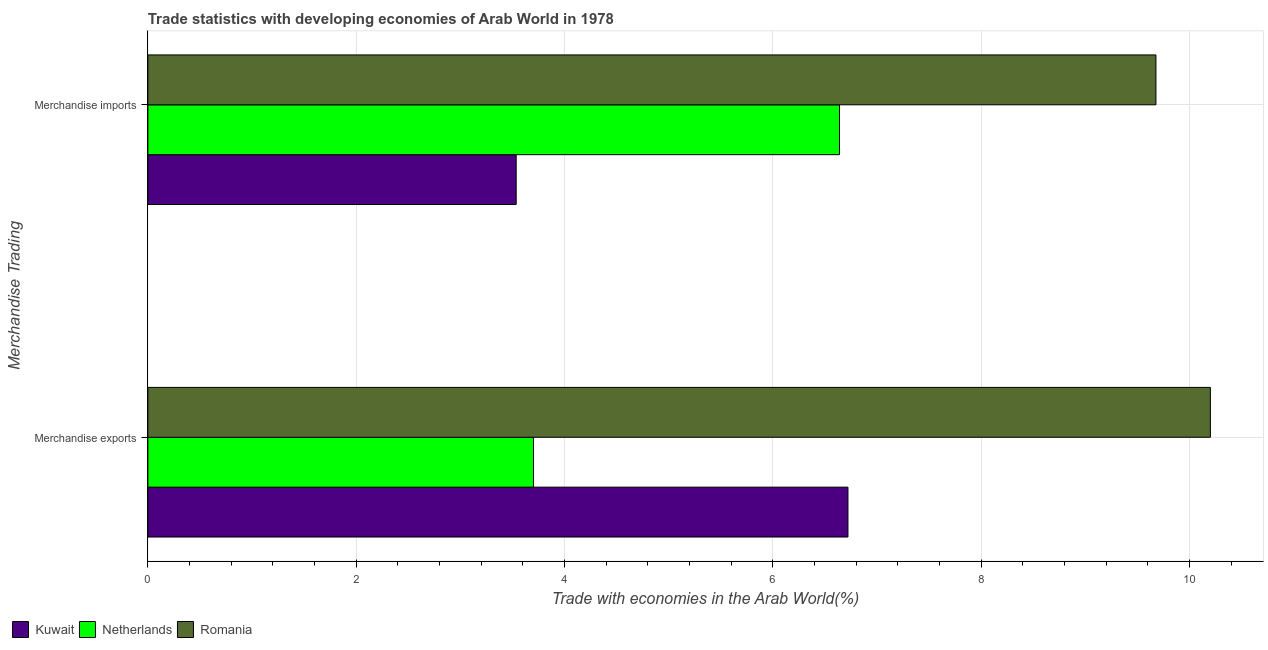Are the number of bars on each tick of the Y-axis equal?
Give a very brief answer. Yes. How many bars are there on the 2nd tick from the top?
Offer a very short reply. 3. What is the merchandise imports in Kuwait?
Provide a succinct answer. 3.54. Across all countries, what is the maximum merchandise imports?
Offer a terse response. 9.68. Across all countries, what is the minimum merchandise exports?
Give a very brief answer. 3.7. In which country was the merchandise imports maximum?
Your answer should be very brief. Romania. In which country was the merchandise imports minimum?
Give a very brief answer. Kuwait. What is the total merchandise exports in the graph?
Provide a short and direct response. 20.62. What is the difference between the merchandise exports in Romania and that in Netherlands?
Keep it short and to the point. 6.5. What is the difference between the merchandise imports in Romania and the merchandise exports in Netherlands?
Your answer should be compact. 5.98. What is the average merchandise imports per country?
Offer a very short reply. 6.62. What is the difference between the merchandise imports and merchandise exports in Romania?
Provide a short and direct response. -0.52. What is the ratio of the merchandise imports in Romania to that in Kuwait?
Your answer should be compact. 2.74. What does the 1st bar from the top in Merchandise imports represents?
Give a very brief answer. Romania. How many bars are there?
Give a very brief answer. 6. Are all the bars in the graph horizontal?
Keep it short and to the point. Yes. Are the values on the major ticks of X-axis written in scientific E-notation?
Give a very brief answer. No. Does the graph contain any zero values?
Offer a very short reply. No. Does the graph contain grids?
Your answer should be very brief. Yes. Where does the legend appear in the graph?
Make the answer very short. Bottom left. How many legend labels are there?
Offer a terse response. 3. What is the title of the graph?
Offer a terse response. Trade statistics with developing economies of Arab World in 1978. What is the label or title of the X-axis?
Offer a terse response. Trade with economies in the Arab World(%). What is the label or title of the Y-axis?
Make the answer very short. Merchandise Trading. What is the Trade with economies in the Arab World(%) of Kuwait in Merchandise exports?
Ensure brevity in your answer.  6.72. What is the Trade with economies in the Arab World(%) in Netherlands in Merchandise exports?
Give a very brief answer. 3.7. What is the Trade with economies in the Arab World(%) in Romania in Merchandise exports?
Provide a short and direct response. 10.2. What is the Trade with economies in the Arab World(%) of Kuwait in Merchandise imports?
Offer a very short reply. 3.54. What is the Trade with economies in the Arab World(%) in Netherlands in Merchandise imports?
Ensure brevity in your answer.  6.64. What is the Trade with economies in the Arab World(%) of Romania in Merchandise imports?
Your answer should be compact. 9.68. Across all Merchandise Trading, what is the maximum Trade with economies in the Arab World(%) in Kuwait?
Give a very brief answer. 6.72. Across all Merchandise Trading, what is the maximum Trade with economies in the Arab World(%) in Netherlands?
Provide a succinct answer. 6.64. Across all Merchandise Trading, what is the maximum Trade with economies in the Arab World(%) in Romania?
Ensure brevity in your answer.  10.2. Across all Merchandise Trading, what is the minimum Trade with economies in the Arab World(%) of Kuwait?
Make the answer very short. 3.54. Across all Merchandise Trading, what is the minimum Trade with economies in the Arab World(%) in Netherlands?
Give a very brief answer. 3.7. Across all Merchandise Trading, what is the minimum Trade with economies in the Arab World(%) in Romania?
Your answer should be very brief. 9.68. What is the total Trade with economies in the Arab World(%) of Kuwait in the graph?
Provide a short and direct response. 10.26. What is the total Trade with economies in the Arab World(%) of Netherlands in the graph?
Provide a short and direct response. 10.34. What is the total Trade with economies in the Arab World(%) in Romania in the graph?
Your answer should be very brief. 19.88. What is the difference between the Trade with economies in the Arab World(%) of Kuwait in Merchandise exports and that in Merchandise imports?
Offer a very short reply. 3.19. What is the difference between the Trade with economies in the Arab World(%) of Netherlands in Merchandise exports and that in Merchandise imports?
Give a very brief answer. -2.94. What is the difference between the Trade with economies in the Arab World(%) in Romania in Merchandise exports and that in Merchandise imports?
Provide a succinct answer. 0.52. What is the difference between the Trade with economies in the Arab World(%) in Kuwait in Merchandise exports and the Trade with economies in the Arab World(%) in Netherlands in Merchandise imports?
Offer a terse response. 0.08. What is the difference between the Trade with economies in the Arab World(%) of Kuwait in Merchandise exports and the Trade with economies in the Arab World(%) of Romania in Merchandise imports?
Offer a very short reply. -2.96. What is the difference between the Trade with economies in the Arab World(%) of Netherlands in Merchandise exports and the Trade with economies in the Arab World(%) of Romania in Merchandise imports?
Your answer should be compact. -5.98. What is the average Trade with economies in the Arab World(%) of Kuwait per Merchandise Trading?
Make the answer very short. 5.13. What is the average Trade with economies in the Arab World(%) of Netherlands per Merchandise Trading?
Offer a very short reply. 5.17. What is the average Trade with economies in the Arab World(%) of Romania per Merchandise Trading?
Offer a very short reply. 9.94. What is the difference between the Trade with economies in the Arab World(%) in Kuwait and Trade with economies in the Arab World(%) in Netherlands in Merchandise exports?
Offer a very short reply. 3.02. What is the difference between the Trade with economies in the Arab World(%) of Kuwait and Trade with economies in the Arab World(%) of Romania in Merchandise exports?
Provide a short and direct response. -3.48. What is the difference between the Trade with economies in the Arab World(%) of Netherlands and Trade with economies in the Arab World(%) of Romania in Merchandise exports?
Make the answer very short. -6.5. What is the difference between the Trade with economies in the Arab World(%) in Kuwait and Trade with economies in the Arab World(%) in Netherlands in Merchandise imports?
Keep it short and to the point. -3.1. What is the difference between the Trade with economies in the Arab World(%) of Kuwait and Trade with economies in the Arab World(%) of Romania in Merchandise imports?
Keep it short and to the point. -6.14. What is the difference between the Trade with economies in the Arab World(%) of Netherlands and Trade with economies in the Arab World(%) of Romania in Merchandise imports?
Your answer should be compact. -3.04. What is the ratio of the Trade with economies in the Arab World(%) in Kuwait in Merchandise exports to that in Merchandise imports?
Your answer should be compact. 1.9. What is the ratio of the Trade with economies in the Arab World(%) in Netherlands in Merchandise exports to that in Merchandise imports?
Provide a succinct answer. 0.56. What is the ratio of the Trade with economies in the Arab World(%) in Romania in Merchandise exports to that in Merchandise imports?
Your response must be concise. 1.05. What is the difference between the highest and the second highest Trade with economies in the Arab World(%) in Kuwait?
Provide a short and direct response. 3.19. What is the difference between the highest and the second highest Trade with economies in the Arab World(%) in Netherlands?
Give a very brief answer. 2.94. What is the difference between the highest and the second highest Trade with economies in the Arab World(%) in Romania?
Your answer should be compact. 0.52. What is the difference between the highest and the lowest Trade with economies in the Arab World(%) of Kuwait?
Your answer should be compact. 3.19. What is the difference between the highest and the lowest Trade with economies in the Arab World(%) in Netherlands?
Give a very brief answer. 2.94. What is the difference between the highest and the lowest Trade with economies in the Arab World(%) of Romania?
Keep it short and to the point. 0.52. 